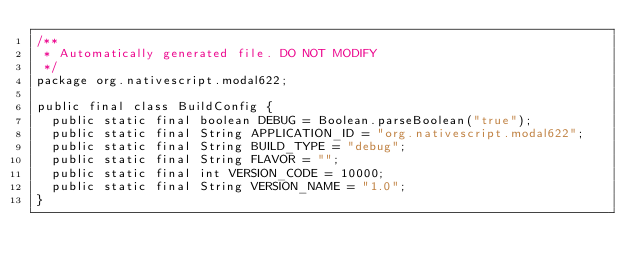Convert code to text. <code><loc_0><loc_0><loc_500><loc_500><_Java_>/**
 * Automatically generated file. DO NOT MODIFY
 */
package org.nativescript.modal622;

public final class BuildConfig {
  public static final boolean DEBUG = Boolean.parseBoolean("true");
  public static final String APPLICATION_ID = "org.nativescript.modal622";
  public static final String BUILD_TYPE = "debug";
  public static final String FLAVOR = "";
  public static final int VERSION_CODE = 10000;
  public static final String VERSION_NAME = "1.0";
}
</code> 